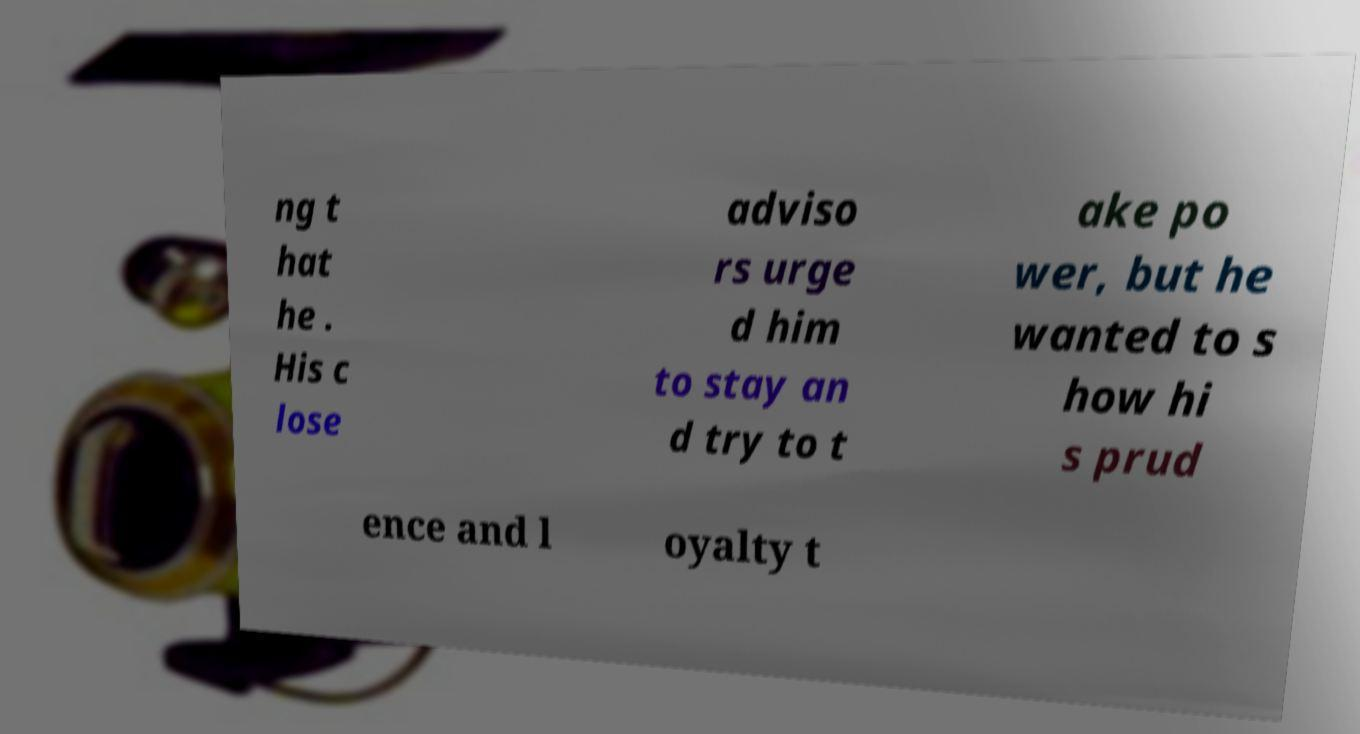I need the written content from this picture converted into text. Can you do that? ng t hat he . His c lose adviso rs urge d him to stay an d try to t ake po wer, but he wanted to s how hi s prud ence and l oyalty t 